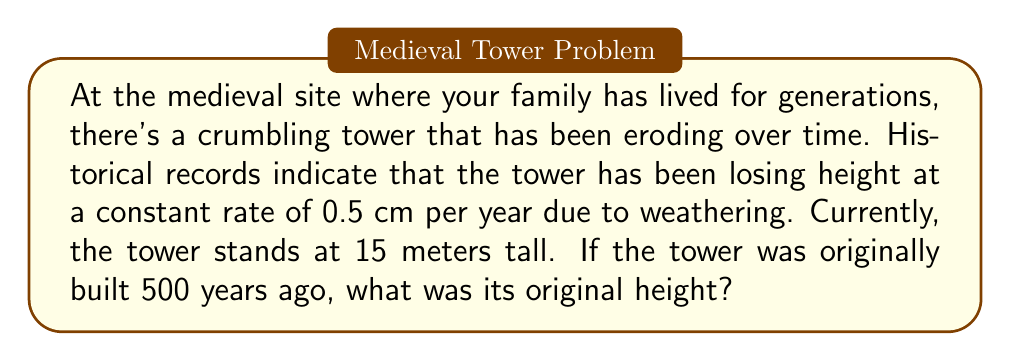Can you answer this question? Let's approach this problem step-by-step:

1) First, we need to identify the known variables:
   - Current height: $h_c = 15$ meters
   - Erosion rate: $r = 0.5$ cm/year = $0.005$ m/year
   - Time elapsed: $t = 500$ years

2) We want to find the original height, let's call it $h_o$.

3) The relationship between the original height and current height can be expressed as:
   $$h_o = h_c + rt$$

   Where:
   $h_o$ is the original height
   $h_c$ is the current height
   $r$ is the erosion rate
   $t$ is the time elapsed

4) Now, let's substitute the known values:
   $$h_o = 15 + 0.005 \times 500$$

5) Let's calculate:
   $$h_o = 15 + 2.5 = 17.5$$

Therefore, the original height of the tower was 17.5 meters.
Answer: 17.5 meters 